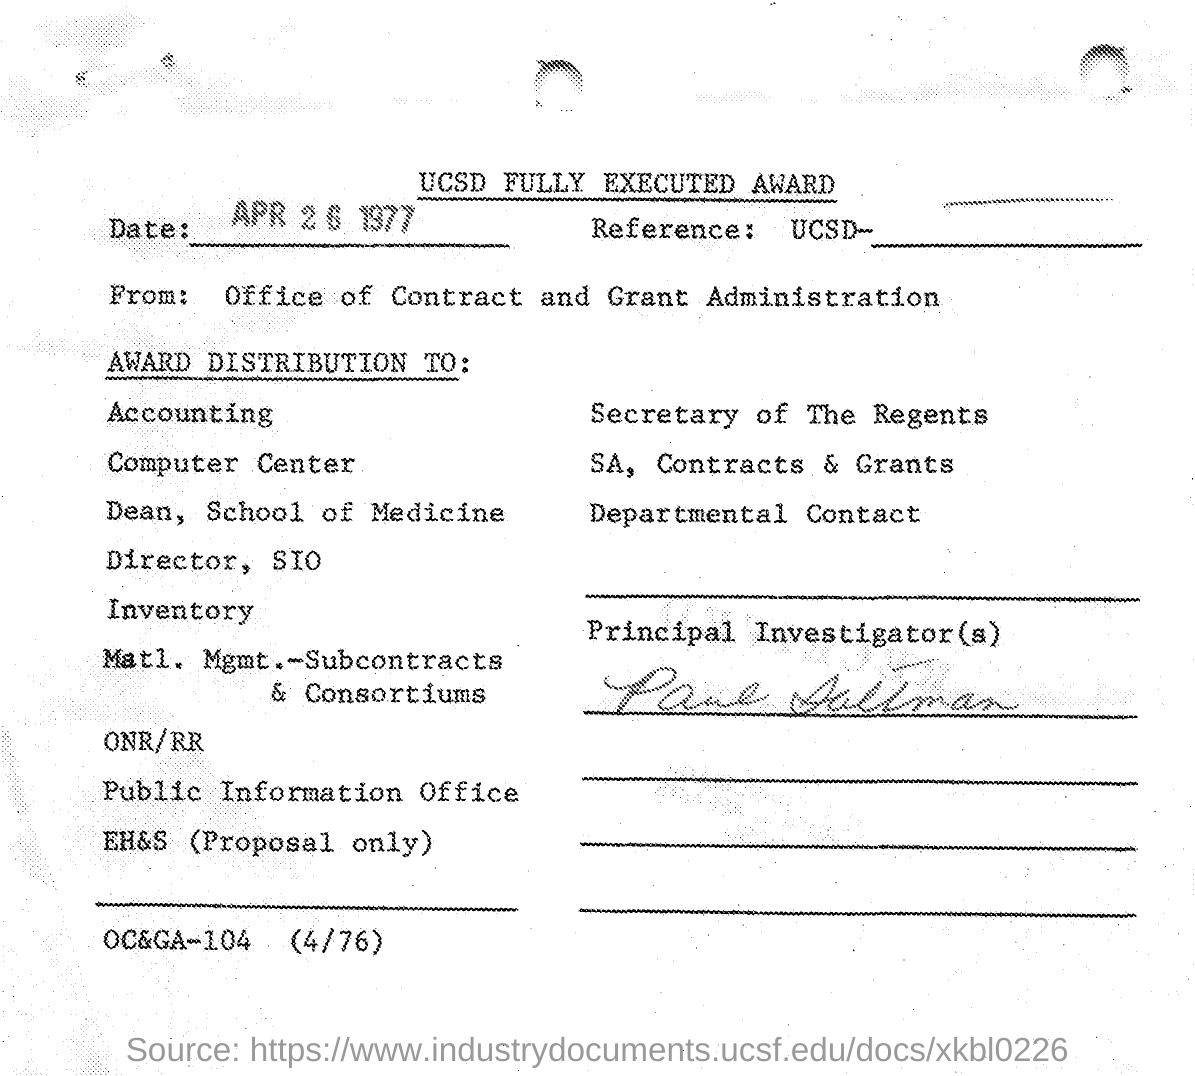Highlight a few significant elements in this photo. The date mentioned on the given page is April 26, 1977. The letter was delivered to the office of contract and grant administration from whom it was received. 